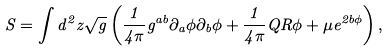<formula> <loc_0><loc_0><loc_500><loc_500>S = \int d ^ { 2 } z \sqrt { g } \left ( \frac { 1 } { 4 \pi } g ^ { a b } \partial _ { a } \phi \partial _ { b } \phi + \frac { 1 } { 4 \pi } Q R \phi + \mu e ^ { 2 b \phi } \right ) ,</formula> 